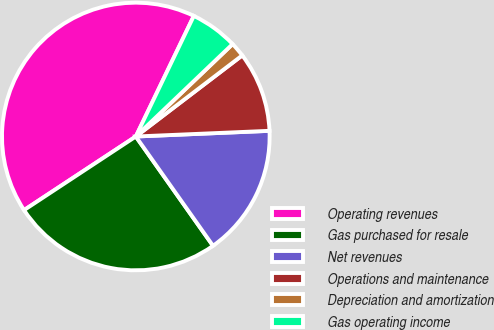<chart> <loc_0><loc_0><loc_500><loc_500><pie_chart><fcel>Operating revenues<fcel>Gas purchased for resale<fcel>Net revenues<fcel>Operations and maintenance<fcel>Depreciation and amortization<fcel>Gas operating income<nl><fcel>41.41%<fcel>25.52%<fcel>15.89%<fcel>9.69%<fcel>1.77%<fcel>5.73%<nl></chart> 